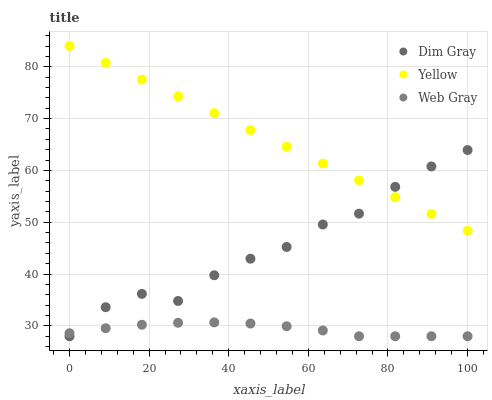Does Web Gray have the minimum area under the curve?
Answer yes or no. Yes. Does Yellow have the maximum area under the curve?
Answer yes or no. Yes. Does Yellow have the minimum area under the curve?
Answer yes or no. No. Does Web Gray have the maximum area under the curve?
Answer yes or no. No. Is Yellow the smoothest?
Answer yes or no. Yes. Is Dim Gray the roughest?
Answer yes or no. Yes. Is Web Gray the smoothest?
Answer yes or no. No. Is Web Gray the roughest?
Answer yes or no. No. Does Dim Gray have the lowest value?
Answer yes or no. Yes. Does Yellow have the lowest value?
Answer yes or no. No. Does Yellow have the highest value?
Answer yes or no. Yes. Does Web Gray have the highest value?
Answer yes or no. No. Is Web Gray less than Yellow?
Answer yes or no. Yes. Is Yellow greater than Web Gray?
Answer yes or no. Yes. Does Web Gray intersect Dim Gray?
Answer yes or no. Yes. Is Web Gray less than Dim Gray?
Answer yes or no. No. Is Web Gray greater than Dim Gray?
Answer yes or no. No. Does Web Gray intersect Yellow?
Answer yes or no. No. 